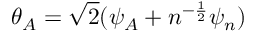<formula> <loc_0><loc_0><loc_500><loc_500>\theta _ { A } = \sqrt { 2 } ( \psi _ { A } + n ^ { - { \frac { 1 } { 2 } } } \psi _ { n } )</formula> 